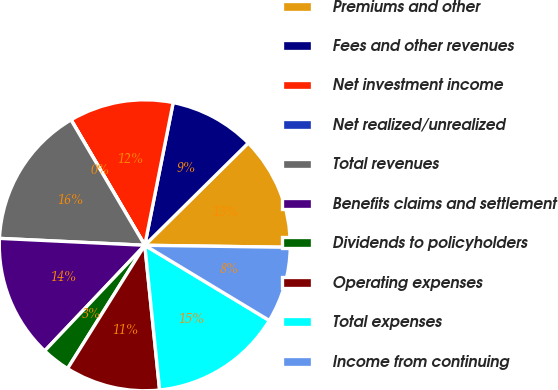<chart> <loc_0><loc_0><loc_500><loc_500><pie_chart><fcel>Premiums and other<fcel>Fees and other revenues<fcel>Net investment income<fcel>Net realized/unrealized<fcel>Total revenues<fcel>Benefits claims and settlement<fcel>Dividends to policyholders<fcel>Operating expenses<fcel>Total expenses<fcel>Income from continuing<nl><fcel>12.63%<fcel>9.47%<fcel>11.58%<fcel>0.01%<fcel>15.78%<fcel>13.68%<fcel>3.17%<fcel>10.53%<fcel>14.73%<fcel>8.42%<nl></chart> 